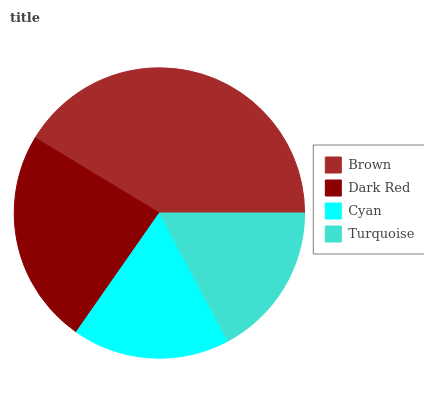Is Turquoise the minimum?
Answer yes or no. Yes. Is Brown the maximum?
Answer yes or no. Yes. Is Dark Red the minimum?
Answer yes or no. No. Is Dark Red the maximum?
Answer yes or no. No. Is Brown greater than Dark Red?
Answer yes or no. Yes. Is Dark Red less than Brown?
Answer yes or no. Yes. Is Dark Red greater than Brown?
Answer yes or no. No. Is Brown less than Dark Red?
Answer yes or no. No. Is Dark Red the high median?
Answer yes or no. Yes. Is Cyan the low median?
Answer yes or no. Yes. Is Brown the high median?
Answer yes or no. No. Is Brown the low median?
Answer yes or no. No. 